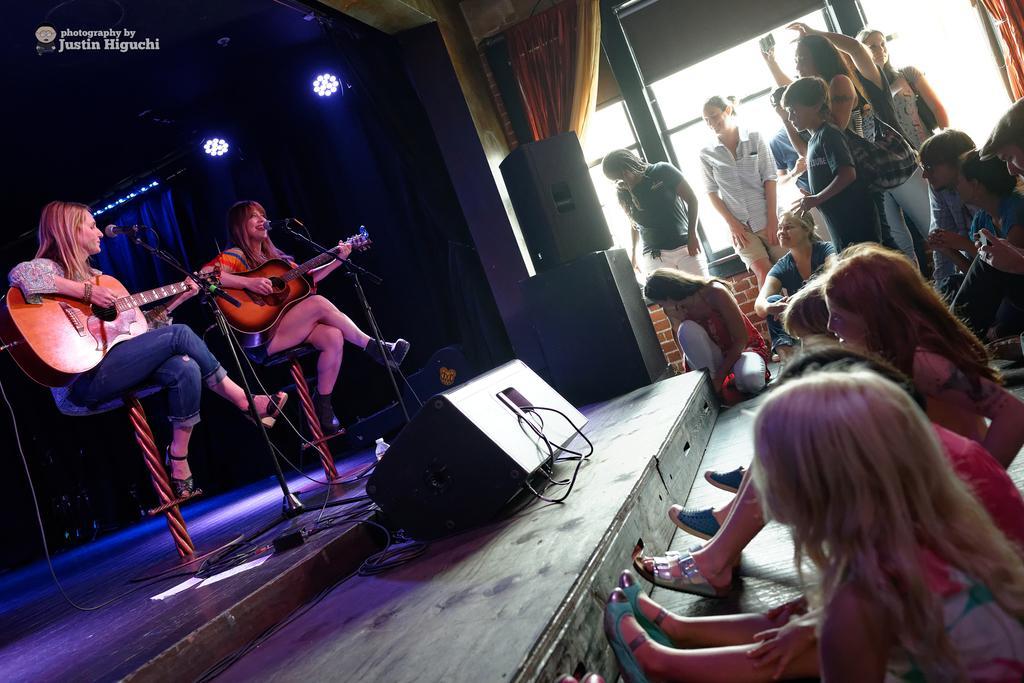How would you summarize this image in a sentence or two? Here we can see two women sitting on chairs in front of a mike and playing guitar. This is a platform. here we can see few persons standing. These are windows and curtains. these are speakers. Here we can see few persons sitting. 